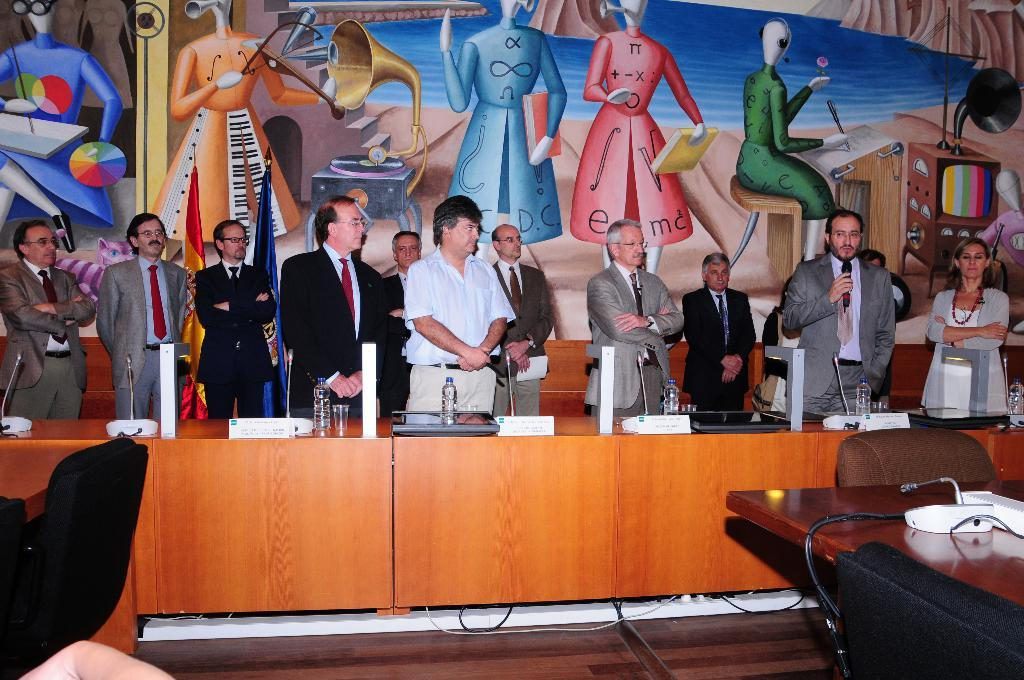What is happening in the middle of the image? There is a group of people standing in the middle of the image. What is the man on the right side of the image doing? The man is speaking into a microphone in the right side of the image. Can you describe the art or artwork visible in the image? There is a beautiful art or artwork visible in the image. Is there a house visible in the image? There is no mention of a house in the provided facts, so we cannot determine if a house is present in the image. How does the artwork stream in the image? The artwork does not stream in the image; it is a static visual element. 